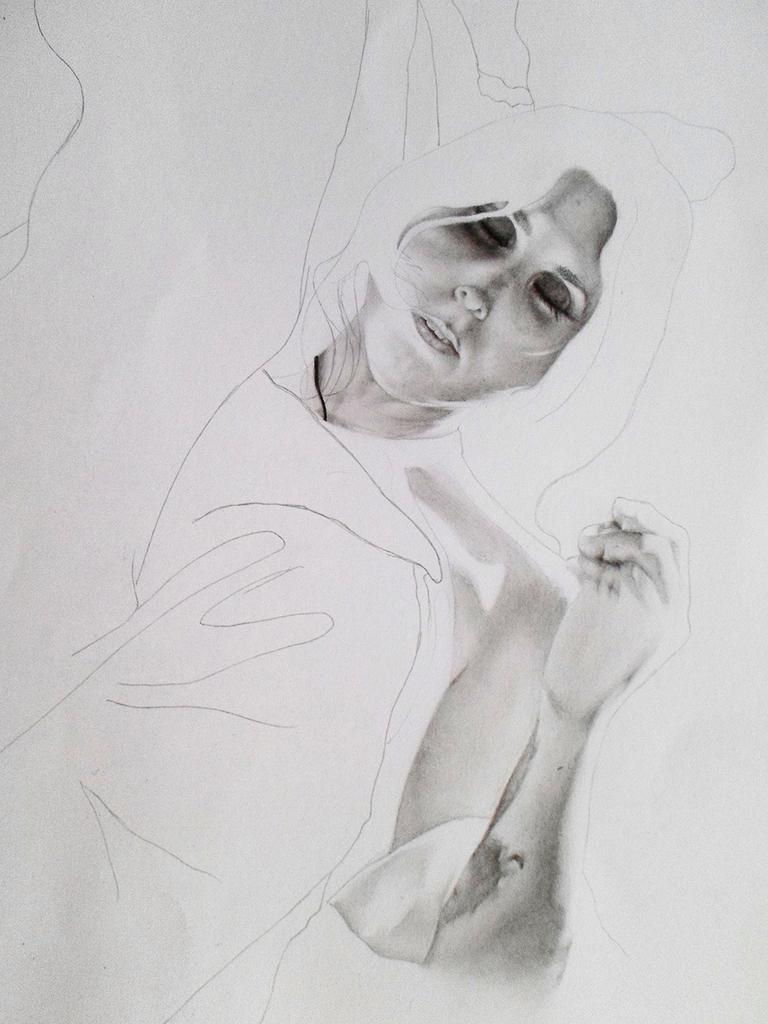What is depicted on the white paper in the image? There is a drawing of a person on a white paper. What specific features of the person are included in the drawing? The drawing includes the person's face and hand. How many cubs are playing with the person in the drawing? There are no cubs present in the drawing; it only depicts a person with their face and hand. 